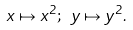<formula> <loc_0><loc_0><loc_500><loc_500>x \mapsto x ^ { 2 } ; \ y \mapsto y ^ { 2 } . \</formula> 